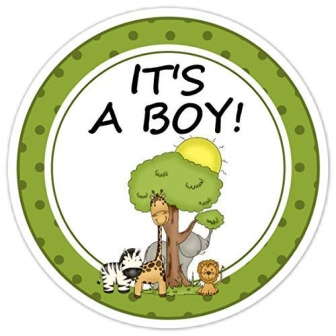Suppose this is an invitation card. What's a creative way to invite guests? "Roar, Stomp, and Chirp! Come join us for a thrilling adventure as we celebrate the arrival of our newest little explorer! Giraffe, Lion, Zebra, and all their friends under the big tree invite you to a joyful baby shower. It's going to be a wild time because 'IT'S A BOY!' Your journey begins on [date] at [location]. Pack your safari hat and your biggest smile; this is one party you won’t want to miss!" 